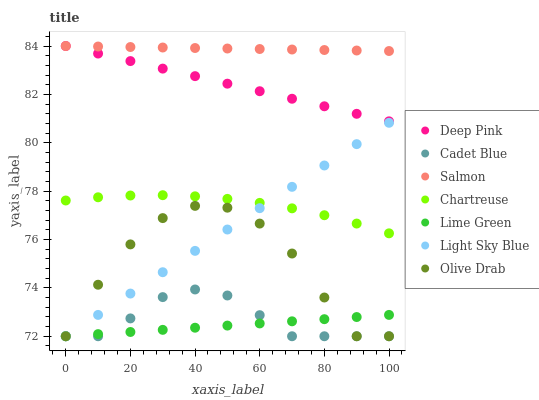Does Lime Green have the minimum area under the curve?
Answer yes or no. Yes. Does Salmon have the maximum area under the curve?
Answer yes or no. Yes. Does Chartreuse have the minimum area under the curve?
Answer yes or no. No. Does Chartreuse have the maximum area under the curve?
Answer yes or no. No. Is Light Sky Blue the smoothest?
Answer yes or no. Yes. Is Olive Drab the roughest?
Answer yes or no. Yes. Is Salmon the smoothest?
Answer yes or no. No. Is Salmon the roughest?
Answer yes or no. No. Does Cadet Blue have the lowest value?
Answer yes or no. Yes. Does Chartreuse have the lowest value?
Answer yes or no. No. Does Deep Pink have the highest value?
Answer yes or no. Yes. Does Chartreuse have the highest value?
Answer yes or no. No. Is Lime Green less than Chartreuse?
Answer yes or no. Yes. Is Salmon greater than Lime Green?
Answer yes or no. Yes. Does Olive Drab intersect Cadet Blue?
Answer yes or no. Yes. Is Olive Drab less than Cadet Blue?
Answer yes or no. No. Is Olive Drab greater than Cadet Blue?
Answer yes or no. No. Does Lime Green intersect Chartreuse?
Answer yes or no. No. 